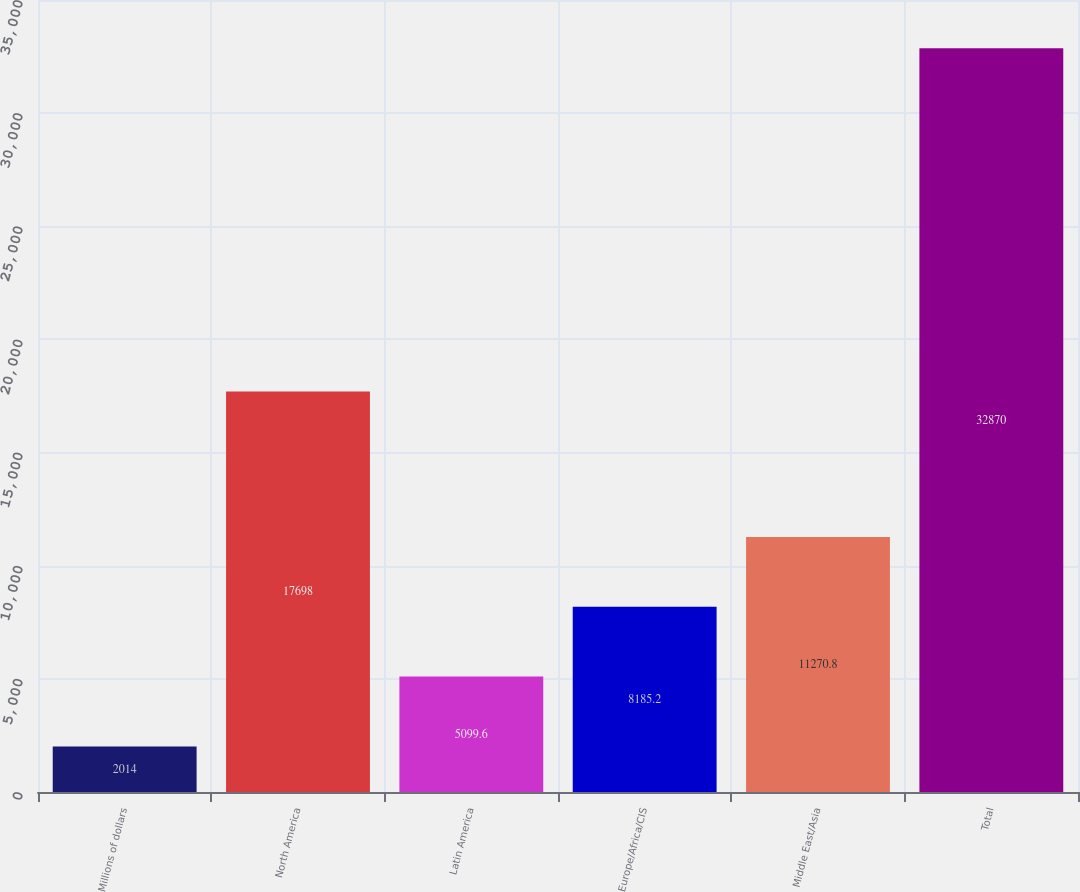Convert chart. <chart><loc_0><loc_0><loc_500><loc_500><bar_chart><fcel>Millions of dollars<fcel>North America<fcel>Latin America<fcel>Europe/Africa/CIS<fcel>Middle East/Asia<fcel>Total<nl><fcel>2014<fcel>17698<fcel>5099.6<fcel>8185.2<fcel>11270.8<fcel>32870<nl></chart> 